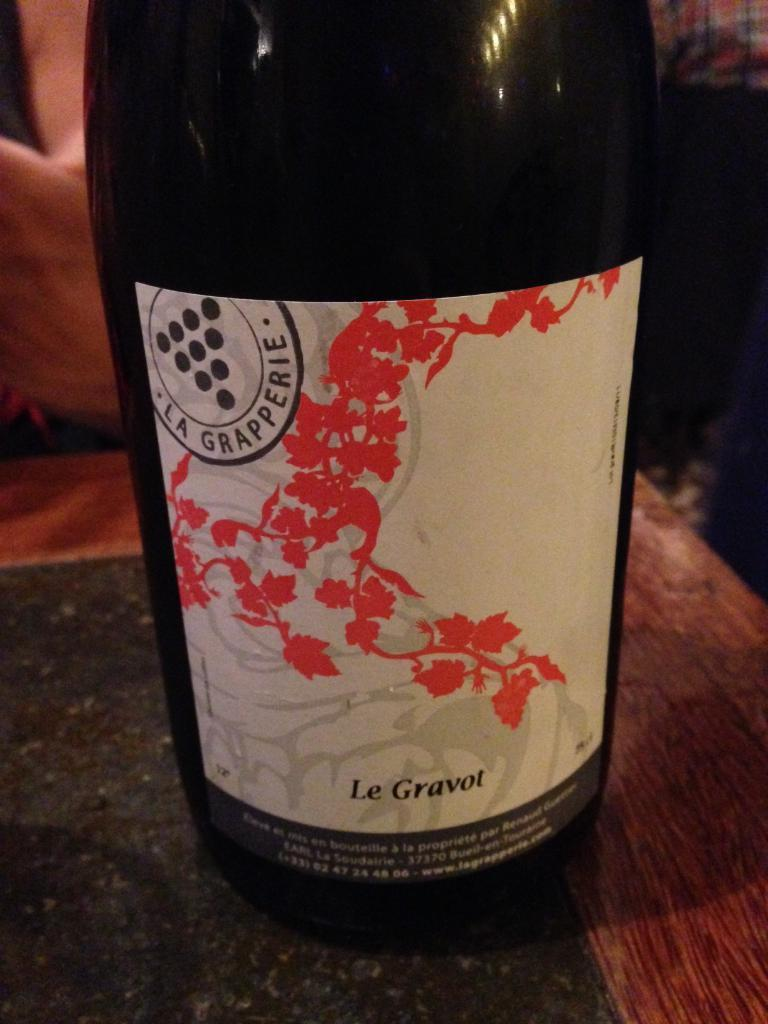What object is present on the surface in the image? There is a bottle in the image. Can you describe the position of the bottle in the image? The bottle is on the surface in the image. What is depicted on the bottle? There is an image on the bottle. What type of information is present on the bottle? There is text on the bottle. What type of jeans can be seen sparking in the image? There are no jeans present in the image, and therefore no such activity can be observed. 